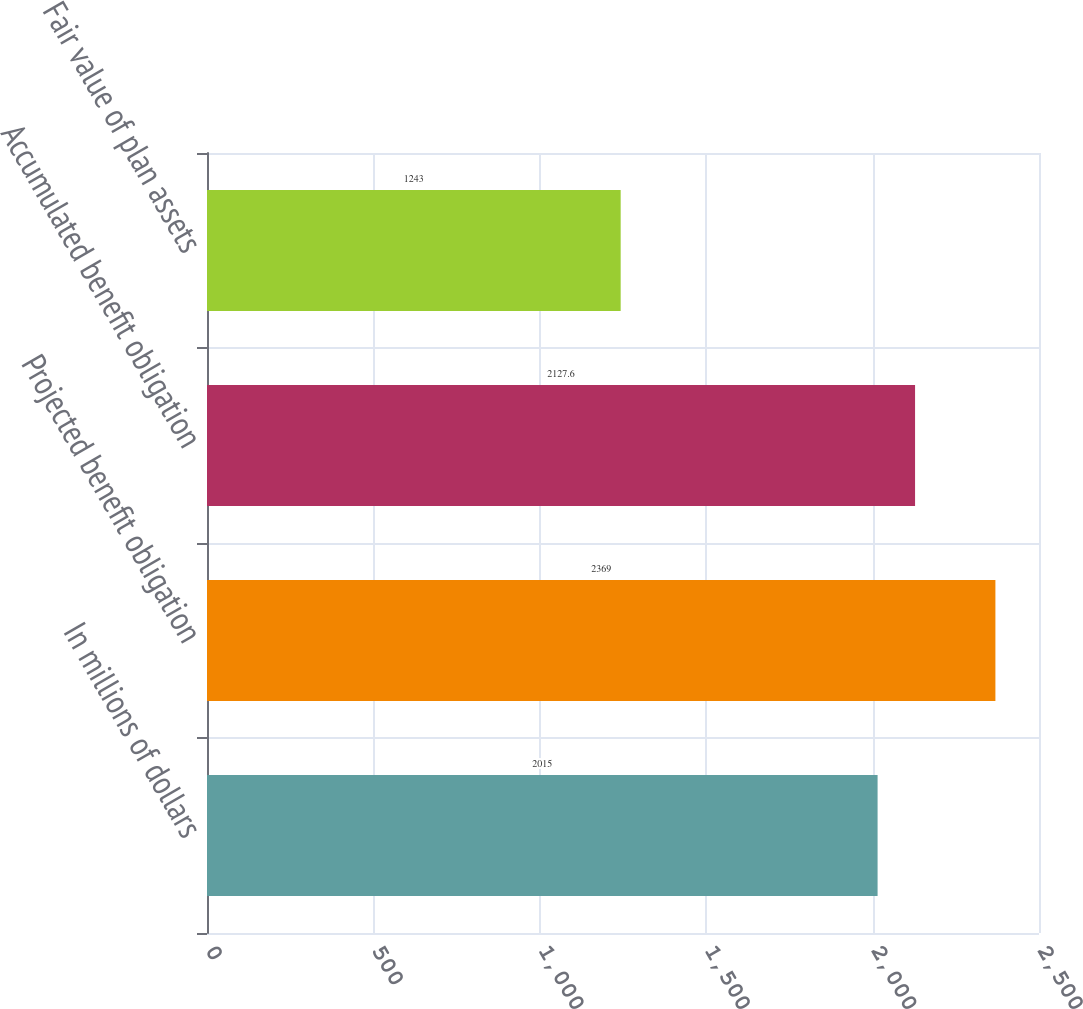<chart> <loc_0><loc_0><loc_500><loc_500><bar_chart><fcel>In millions of dollars<fcel>Projected benefit obligation<fcel>Accumulated benefit obligation<fcel>Fair value of plan assets<nl><fcel>2015<fcel>2369<fcel>2127.6<fcel>1243<nl></chart> 